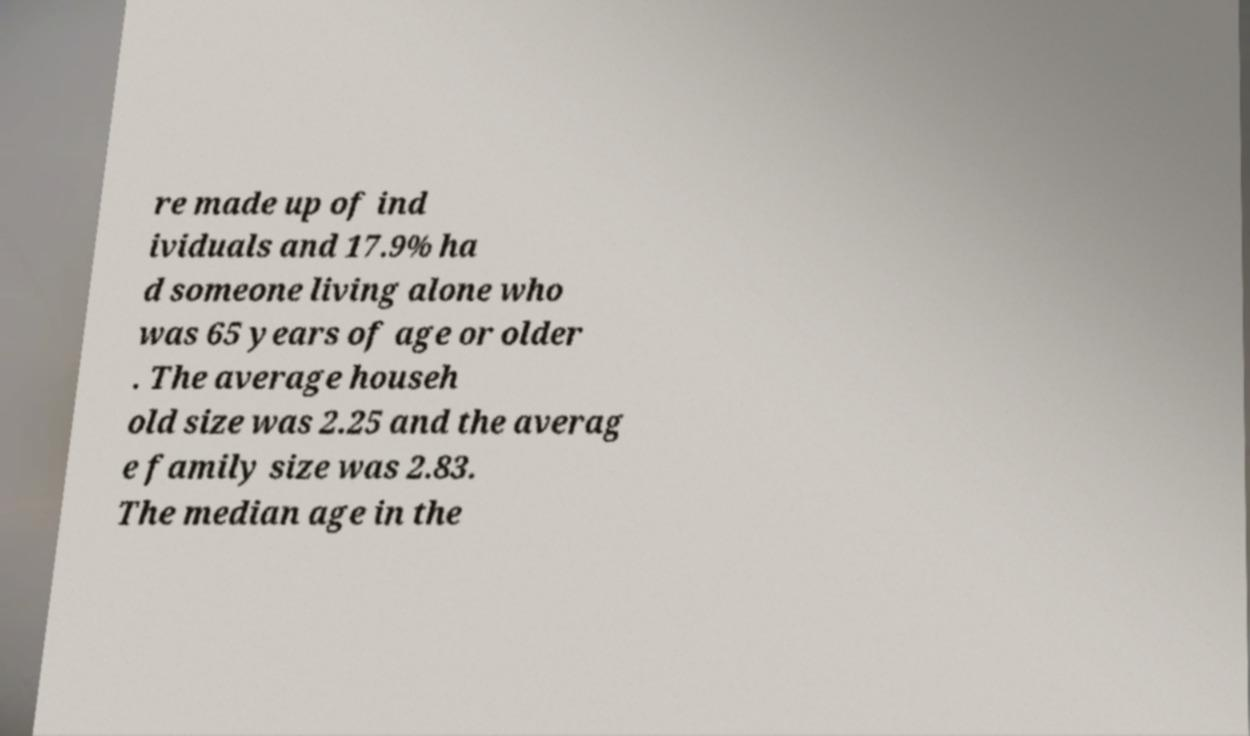What messages or text are displayed in this image? I need them in a readable, typed format. re made up of ind ividuals and 17.9% ha d someone living alone who was 65 years of age or older . The average househ old size was 2.25 and the averag e family size was 2.83. The median age in the 